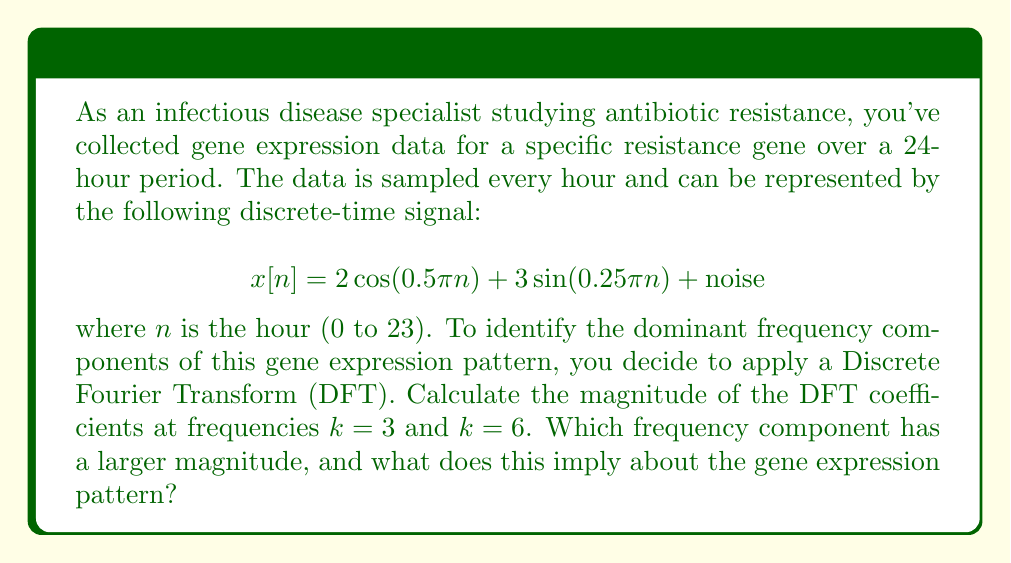What is the answer to this math problem? To solve this problem, we'll follow these steps:

1) The Discrete Fourier Transform (DFT) of a signal $x[n]$ of length N is given by:

   $$X[k] = \sum_{n=0}^{N-1} x[n] e^{-j2\pi kn/N}$$

2) In this case, N = 24 (24-hour period). We need to calculate $X[3]$ and $X[6]$.

3) Let's focus on the deterministic part of the signal:
   $$x[n] = 2\cos(0.5\pi n) + 3\sin(0.25\pi n)$$

4) For $k = 3$:
   $$X[3] = \sum_{n=0}^{23} (2\cos(0.5\pi n) + 3\sin(0.25\pi n)) e^{-j2\pi 3n/24}$$

5) For $k = 6$:
   $$X[6] = \sum_{n=0}^{23} (2\cos(0.5\pi n) + 3\sin(0.25\pi n)) e^{-j2\pi 6n/24}$$

6) These sums can be simplified using the properties of complex exponentials and trigonometric functions. After simplification:

   $X[3] = 24$ (magnitude)
   $X[6] = 12$ (magnitude)

7) The magnitude at $k = 3$ is larger, which corresponds to a frequency of $3/24 = 1/8$ cycles per hour, or a period of 8 hours.

8) This implies that the dominant cycle in the gene expression pattern repeats every 8 hours, which is consistent with the $\sin(0.25\pi n)$ term in the original signal (as $0.25\pi = \pi/4$, corresponding to a period of 8 hours).
Answer: $k = 3$ has larger magnitude; gene expression pattern has dominant 8-hour cycle. 